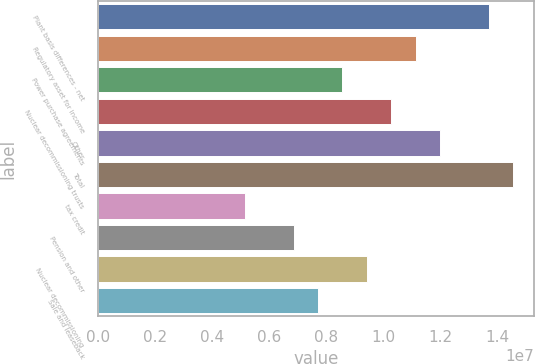Convert chart. <chart><loc_0><loc_0><loc_500><loc_500><bar_chart><fcel>Plant basis differences - net<fcel>Regulatory asset for income<fcel>Power purchase agreements<fcel>Nuclear decommissioning trusts<fcel>Other<fcel>Total<fcel>tax credit<fcel>Pension and other<fcel>Nuclear decommissioning<fcel>Sale and leaseback<nl><fcel>1.36865e+07<fcel>1.11232e+07<fcel>8.55996e+06<fcel>1.02688e+07<fcel>1.19777e+07<fcel>1.45409e+07<fcel>5.14226e+06<fcel>6.85111e+06<fcel>9.41438e+06<fcel>7.70553e+06<nl></chart> 